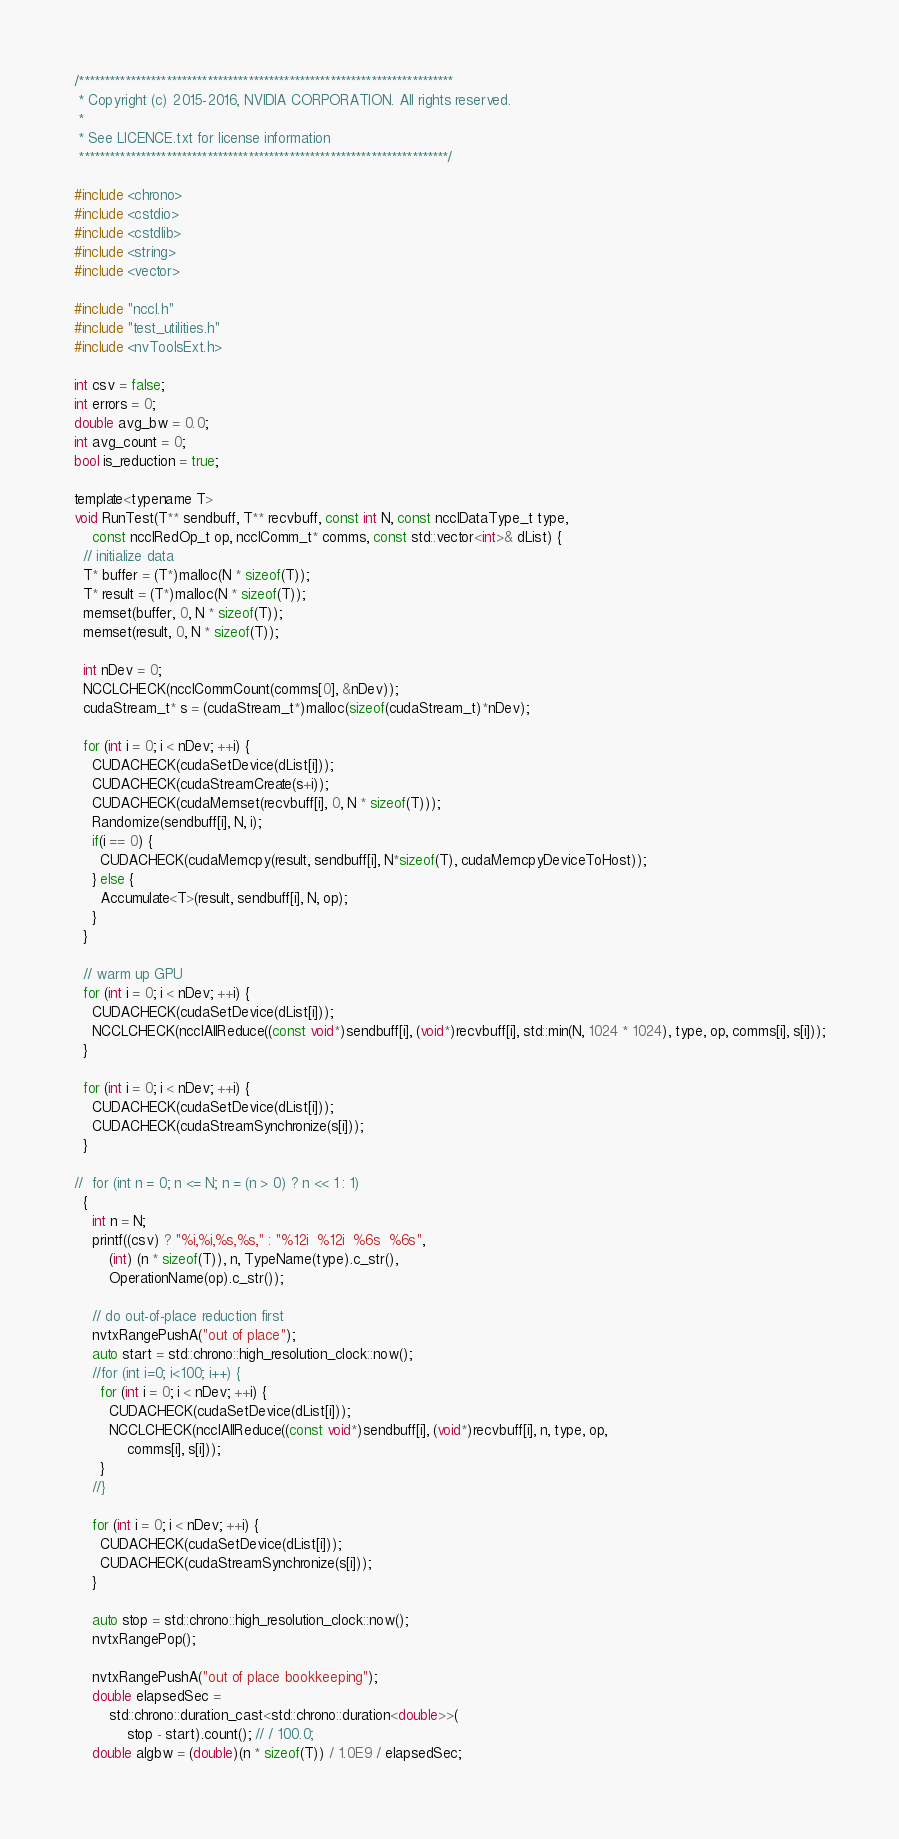Convert code to text. <code><loc_0><loc_0><loc_500><loc_500><_Cuda_>/*************************************************************************
 * Copyright (c) 2015-2016, NVIDIA CORPORATION. All rights reserved.
 *
 * See LICENCE.txt for license information
 ************************************************************************/

#include <chrono>
#include <cstdio>
#include <cstdlib>
#include <string>
#include <vector>

#include "nccl.h"
#include "test_utilities.h"
#include <nvToolsExt.h>

int csv = false;
int errors = 0;
double avg_bw = 0.0;
int avg_count = 0;
bool is_reduction = true;

template<typename T>
void RunTest(T** sendbuff, T** recvbuff, const int N, const ncclDataType_t type,
    const ncclRedOp_t op, ncclComm_t* comms, const std::vector<int>& dList) {
  // initialize data
  T* buffer = (T*)malloc(N * sizeof(T));
  T* result = (T*)malloc(N * sizeof(T));
  memset(buffer, 0, N * sizeof(T));
  memset(result, 0, N * sizeof(T));

  int nDev = 0;
  NCCLCHECK(ncclCommCount(comms[0], &nDev));
  cudaStream_t* s = (cudaStream_t*)malloc(sizeof(cudaStream_t)*nDev);

  for (int i = 0; i < nDev; ++i) {
    CUDACHECK(cudaSetDevice(dList[i]));
    CUDACHECK(cudaStreamCreate(s+i));
    CUDACHECK(cudaMemset(recvbuff[i], 0, N * sizeof(T)));
    Randomize(sendbuff[i], N, i);
    if(i == 0) {
      CUDACHECK(cudaMemcpy(result, sendbuff[i], N*sizeof(T), cudaMemcpyDeviceToHost));
    } else {
      Accumulate<T>(result, sendbuff[i], N, op);
    }
  }

  // warm up GPU
  for (int i = 0; i < nDev; ++i) {
    CUDACHECK(cudaSetDevice(dList[i]));
    NCCLCHECK(ncclAllReduce((const void*)sendbuff[i], (void*)recvbuff[i], std::min(N, 1024 * 1024), type, op, comms[i], s[i]));
  }

  for (int i = 0; i < nDev; ++i) {
    CUDACHECK(cudaSetDevice(dList[i]));
    CUDACHECK(cudaStreamSynchronize(s[i]));
  }

//  for (int n = 0; n <= N; n = (n > 0) ? n << 1 : 1)
  {
    int n = N;
    printf((csv) ? "%i,%i,%s,%s," : "%12i  %12i  %6s  %6s",
        (int) (n * sizeof(T)), n, TypeName(type).c_str(),
        OperationName(op).c_str());

    // do out-of-place reduction first
    nvtxRangePushA("out of place");
    auto start = std::chrono::high_resolution_clock::now();
    //for (int i=0; i<100; i++) {
      for (int i = 0; i < nDev; ++i) {
        CUDACHECK(cudaSetDevice(dList[i]));
        NCCLCHECK(ncclAllReduce((const void*)sendbuff[i], (void*)recvbuff[i], n, type, op,
            comms[i], s[i]));
      }
    //}

    for (int i = 0; i < nDev; ++i) {
      CUDACHECK(cudaSetDevice(dList[i]));
      CUDACHECK(cudaStreamSynchronize(s[i]));
    }

    auto stop = std::chrono::high_resolution_clock::now();
    nvtxRangePop();

    nvtxRangePushA("out of place bookkeeping");
    double elapsedSec =
        std::chrono::duration_cast<std::chrono::duration<double>>(
            stop - start).count(); // / 100.0;
    double algbw = (double)(n * sizeof(T)) / 1.0E9 / elapsedSec;</code> 